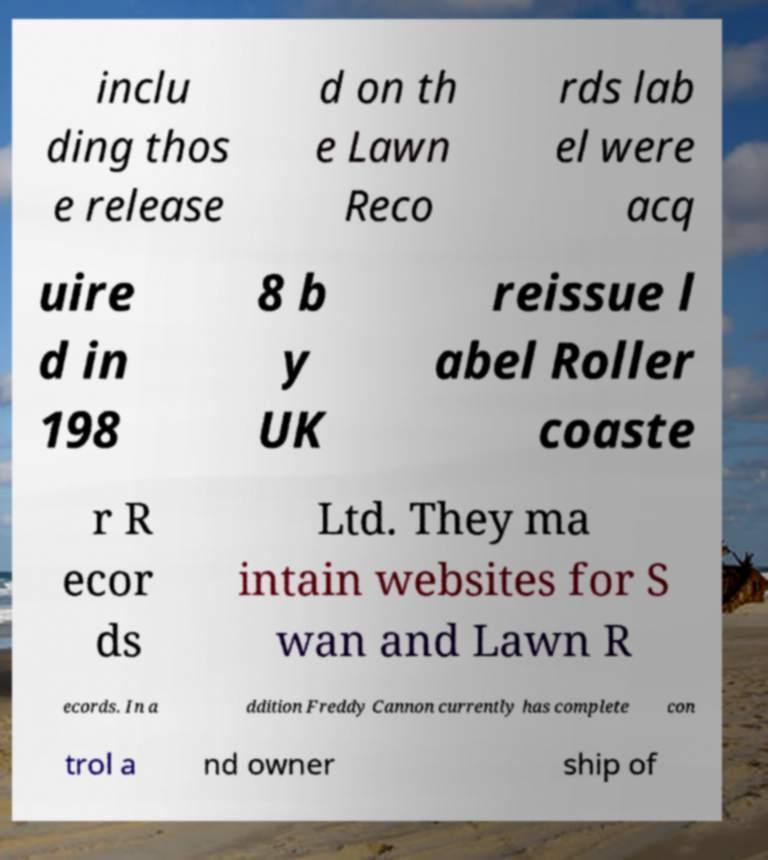Could you assist in decoding the text presented in this image and type it out clearly? inclu ding thos e release d on th e Lawn Reco rds lab el were acq uire d in 198 8 b y UK reissue l abel Roller coaste r R ecor ds Ltd. They ma intain websites for S wan and Lawn R ecords. In a ddition Freddy Cannon currently has complete con trol a nd owner ship of 